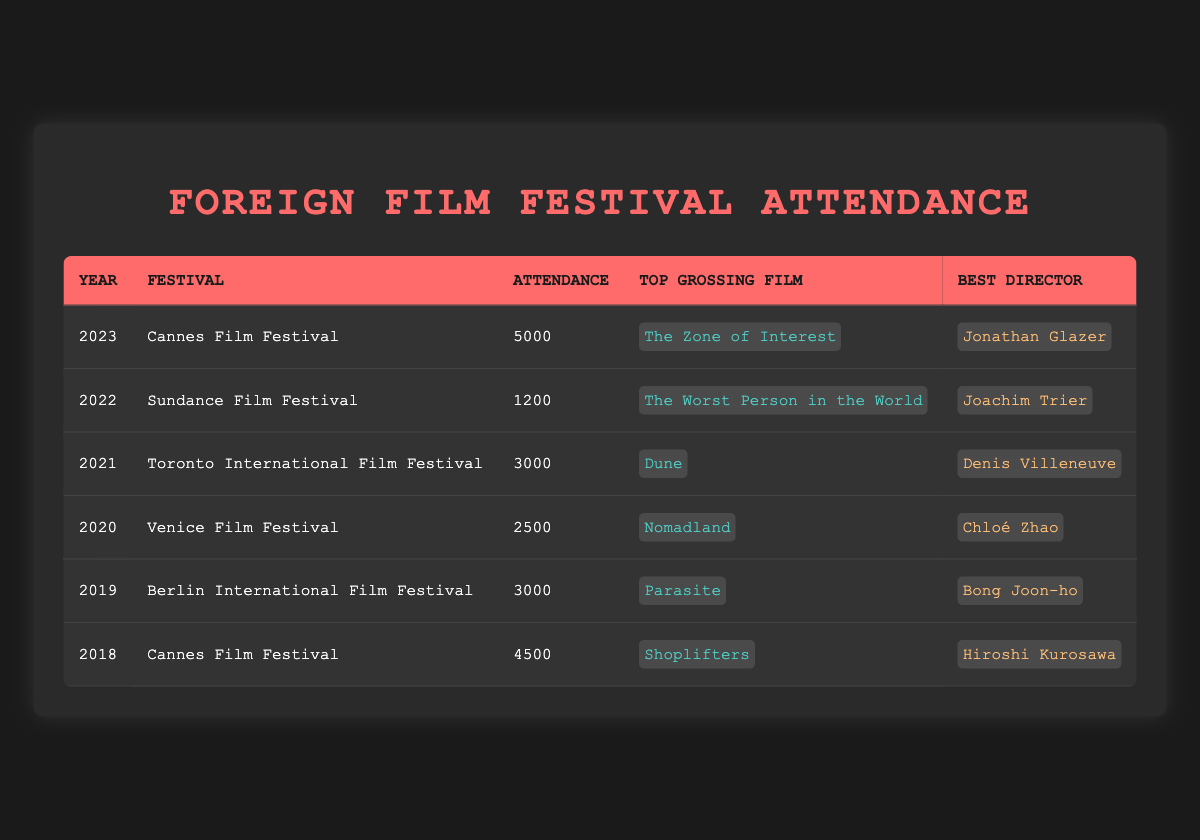What was the attendance at the Cannes Film Festival in 2023? The table shows that the attendance at the Cannes Film Festival in 2023 was 5000.
Answer: 5000 Which film was the top-grossing at the Berlin International Film Festival in 2019? According to the table, the top-grossing film at the Berlin International Film Festival in 2019 was "Parasite."
Answer: Parasite Did the attendance at the Sundance Film Festival increase from 2022 to 2023? The attendance in 2022 was 1200, while in 2023, it was 5000. Since 5000 is greater than 1200, the attendance did increase.
Answer: Yes What is the average attendance of the festivals listed from 2018 to 2022? To find the average, we first sum the attendance: 4500 (2018) + 3000 (2019) + 2500 (2020) + 3000 (2021) + 1200 (2022) = 14200. Next, we divide by the number of years (5), giving us 14200 / 5 = 2840.
Answer: 2840 Which festival had the highest attendance, and what was the top-grossing film associated with it? The highest attendance is 5000 at the Cannes Film Festival in 2023. Its top-grossing film was "The Zone of Interest."
Answer: Cannes Film Festival, The Zone of Interest Were there any festivals with an attendance below 3000? According to the table, the Sundance Film Festival in 2022 had an attendance of 1200, and the Venice Film Festival in 2020 had an attendance of 2500, both of which are below 3000.
Answer: Yes What year saw the introduction of "Nomadland" as the top-grossing film? The table indicates that "Nomadland" was the top-grossing film at the Venice Film Festival in 2020.
Answer: 2020 How many festivals listed had their top-grossing films directed by female directors? "Nomadland" directed by Chloé Zhao in 2020 and "The Worst Person in the World" directed by Joachim Trier in 2022 are the only two; hence, there are two festivals corresponding to female directors.
Answer: 2 What is the difference in attendance between the Cannes Film Festival in 2018 and the Sundance Film Festival in 2022? The attendance for the Cannes Film Festival in 2018 was 4500 and for the Sundance Film Festival in 2022 was 1200. The difference is 4500 - 1200 = 3300.
Answer: 3300 Which director won the Best Director award at the Toronto International Film Festival in 2021? The table states that Denis Villeneuve was awarded Best Director at the Toronto International Film Festival in 2021.
Answer: Denis Villeneuve 